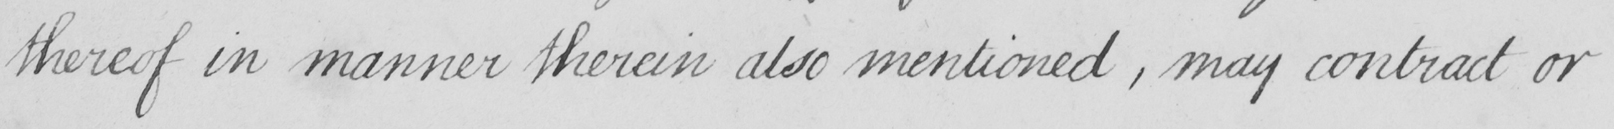What text is written in this handwritten line? thereof in manner therein also mentioned , may contract or 